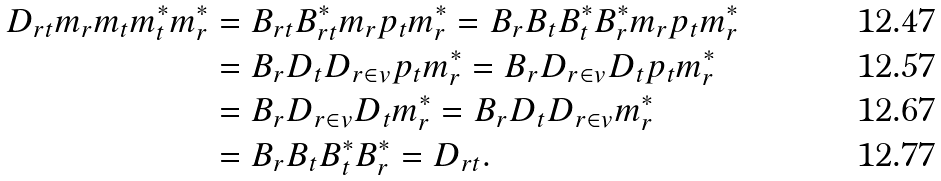Convert formula to latex. <formula><loc_0><loc_0><loc_500><loc_500>D _ { r t } m _ { r } m _ { t } m ^ { * } _ { t } m ^ { * } _ { r } & = B _ { r t } B ^ { * } _ { r t } m _ { r } p _ { t } m ^ { * } _ { r } = B _ { r } B _ { t } B ^ { * } _ { t } B ^ { * } _ { r } m _ { r } p _ { t } m ^ { * } _ { r } \\ & = B _ { r } D _ { t } D _ { r \in v } p _ { t } m ^ { * } _ { r } = B _ { r } D _ { r \in v } D _ { t } p _ { t } m ^ { * } _ { r } \\ & = B _ { r } D _ { r \in v } D _ { t } m ^ { * } _ { r } = B _ { r } D _ { t } D _ { r \in v } m ^ { * } _ { r } \\ & = B _ { r } B _ { t } B ^ { * } _ { t } B ^ { * } _ { r } = D _ { r t } .</formula> 